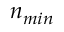Convert formula to latex. <formula><loc_0><loc_0><loc_500><loc_500>n _ { \min }</formula> 